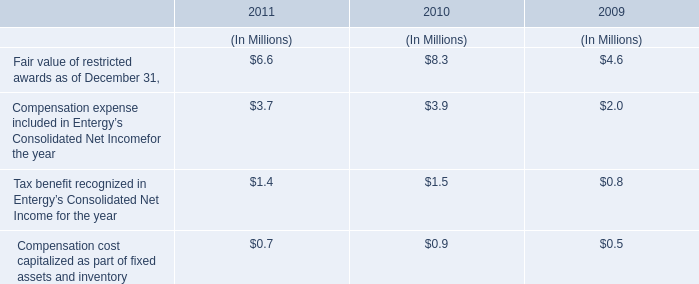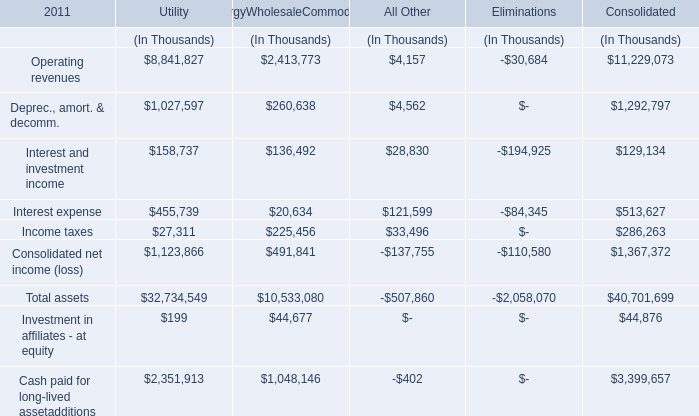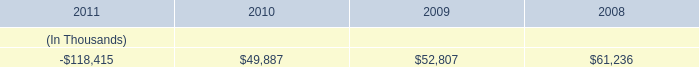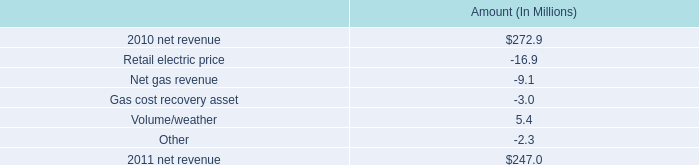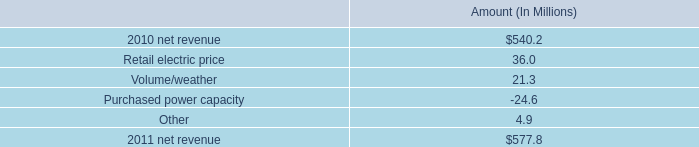from the change in net revenue in 2011 , what percentage is attributed to change in retail electric price? 
Computations: (-16.9 / (247.0 - 272.9))
Answer: 0.65251. 